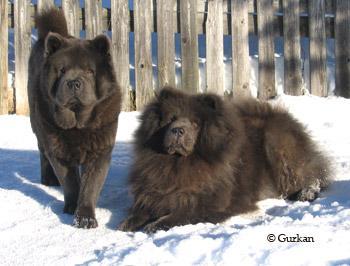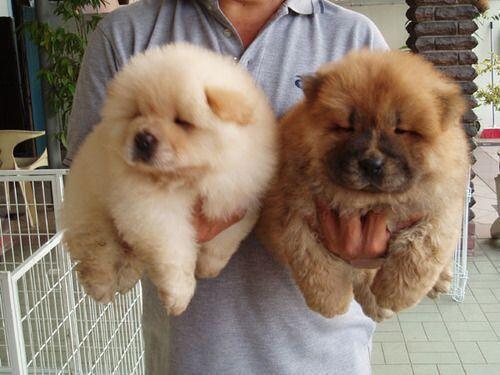The first image is the image on the left, the second image is the image on the right. For the images shown, is this caption "At least one human is interacting with at least one dog, in one of the images." true? Answer yes or no. Yes. 